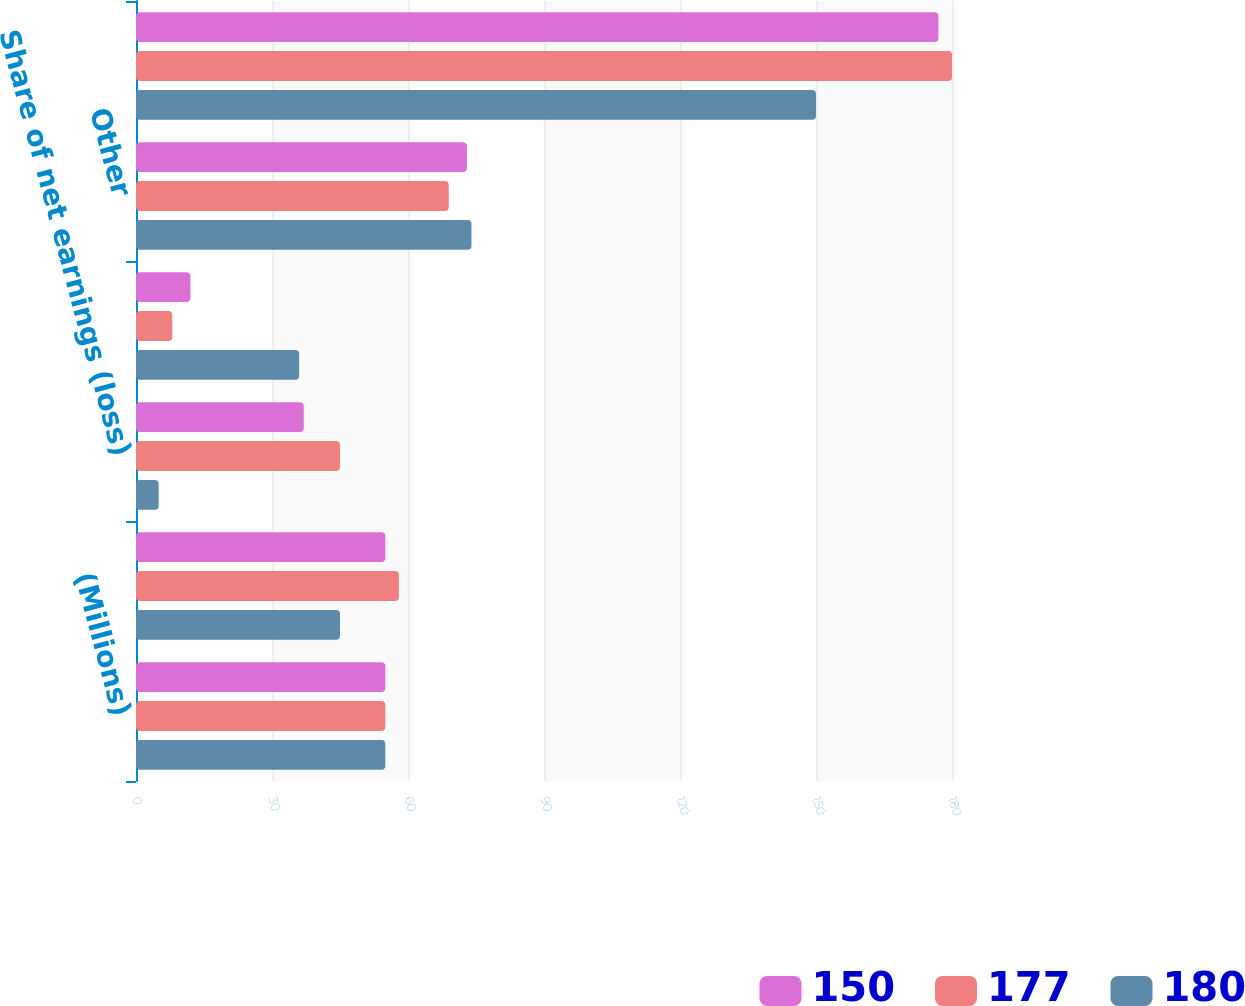Convert chart. <chart><loc_0><loc_0><loc_500><loc_500><stacked_bar_chart><ecel><fcel>(Millions)<fcel>Royalty income<fcel>Share of net earnings (loss)<fcel>Gain on sale of assets<fcel>Other<fcel>Total<nl><fcel>150<fcel>55<fcel>55<fcel>37<fcel>12<fcel>73<fcel>177<nl><fcel>177<fcel>55<fcel>58<fcel>45<fcel>8<fcel>69<fcel>180<nl><fcel>180<fcel>55<fcel>45<fcel>5<fcel>36<fcel>74<fcel>150<nl></chart> 